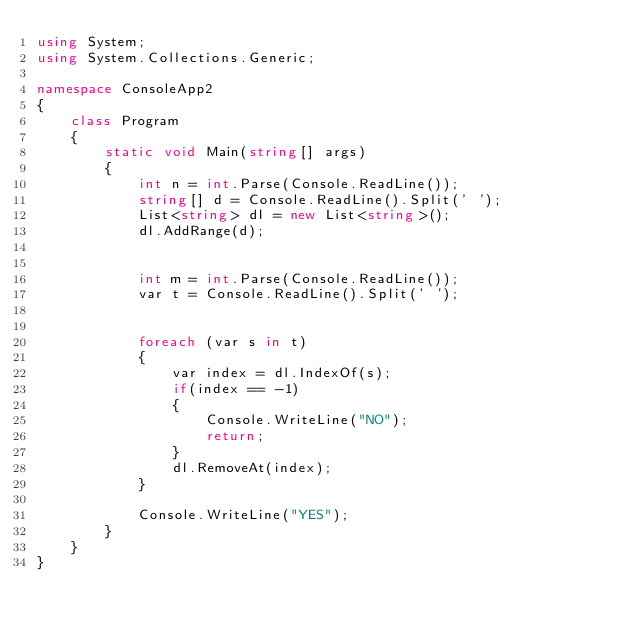<code> <loc_0><loc_0><loc_500><loc_500><_C#_>using System;
using System.Collections.Generic;

namespace ConsoleApp2
{
    class Program
    {
        static void Main(string[] args)
        {
            int n = int.Parse(Console.ReadLine());
            string[] d = Console.ReadLine().Split(' ');
            List<string> dl = new List<string>();
            dl.AddRange(d);


            int m = int.Parse(Console.ReadLine());
            var t = Console.ReadLine().Split(' ');


            foreach (var s in t)
            {
                var index = dl.IndexOf(s);
                if(index == -1)
                {
                    Console.WriteLine("NO");
                    return;
                }
                dl.RemoveAt(index);
            }

            Console.WriteLine("YES");
        }
    }
}
</code> 